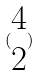<formula> <loc_0><loc_0><loc_500><loc_500>( \begin{matrix} 4 \\ 2 \end{matrix} )</formula> 